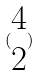<formula> <loc_0><loc_0><loc_500><loc_500>( \begin{matrix} 4 \\ 2 \end{matrix} )</formula> 